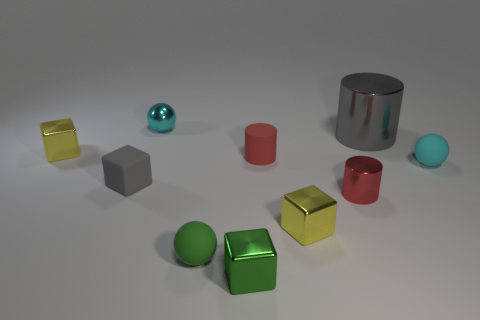What number of objects are yellow metal cubes or cylinders?
Your answer should be very brief. 5. What color is the small shiny cube that is on the right side of the small red matte cylinder?
Your answer should be very brief. Yellow. The gray metal thing that is the same shape as the red metal object is what size?
Offer a terse response. Large. How many things are cyan balls that are left of the tiny red metal cylinder or metallic blocks that are to the right of the green shiny cube?
Keep it short and to the point. 2. There is a metallic object that is both right of the tiny green rubber ball and behind the small gray rubber cube; how big is it?
Make the answer very short. Large. Does the cyan matte object have the same shape as the green thing behind the tiny green metal object?
Make the answer very short. Yes. How many things are tiny things to the left of the tiny green sphere or shiny spheres?
Ensure brevity in your answer.  3. Does the large cylinder have the same material as the small yellow block that is in front of the small gray object?
Make the answer very short. Yes. The small green thing that is behind the tiny green metallic cube in front of the large object is what shape?
Your response must be concise. Sphere. There is a tiny shiny cylinder; is it the same color as the cylinder on the left side of the small metallic cylinder?
Your response must be concise. Yes. 